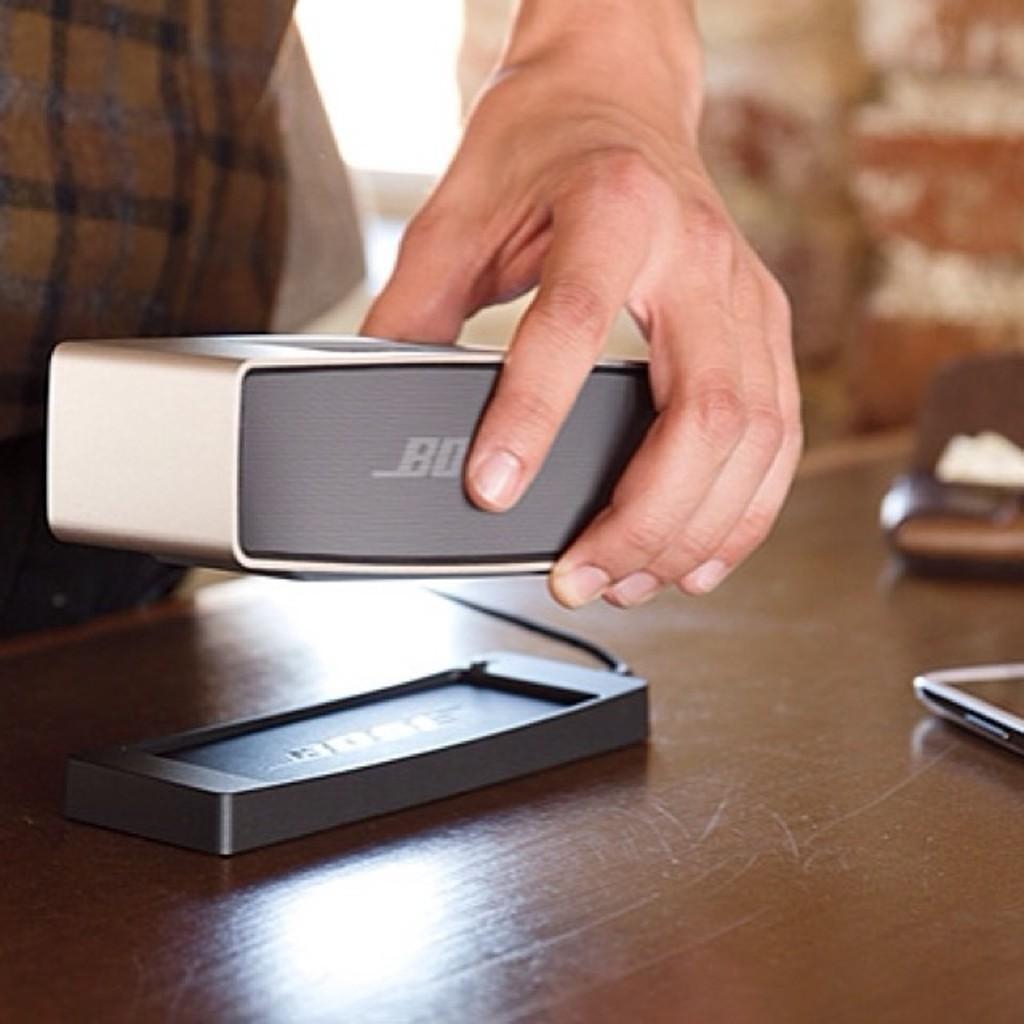Describe this image in one or two sentences. At the bottom of the image there is a table, on the table there are some electronic devices. Behind the table a person is standing and holding a speaker. 